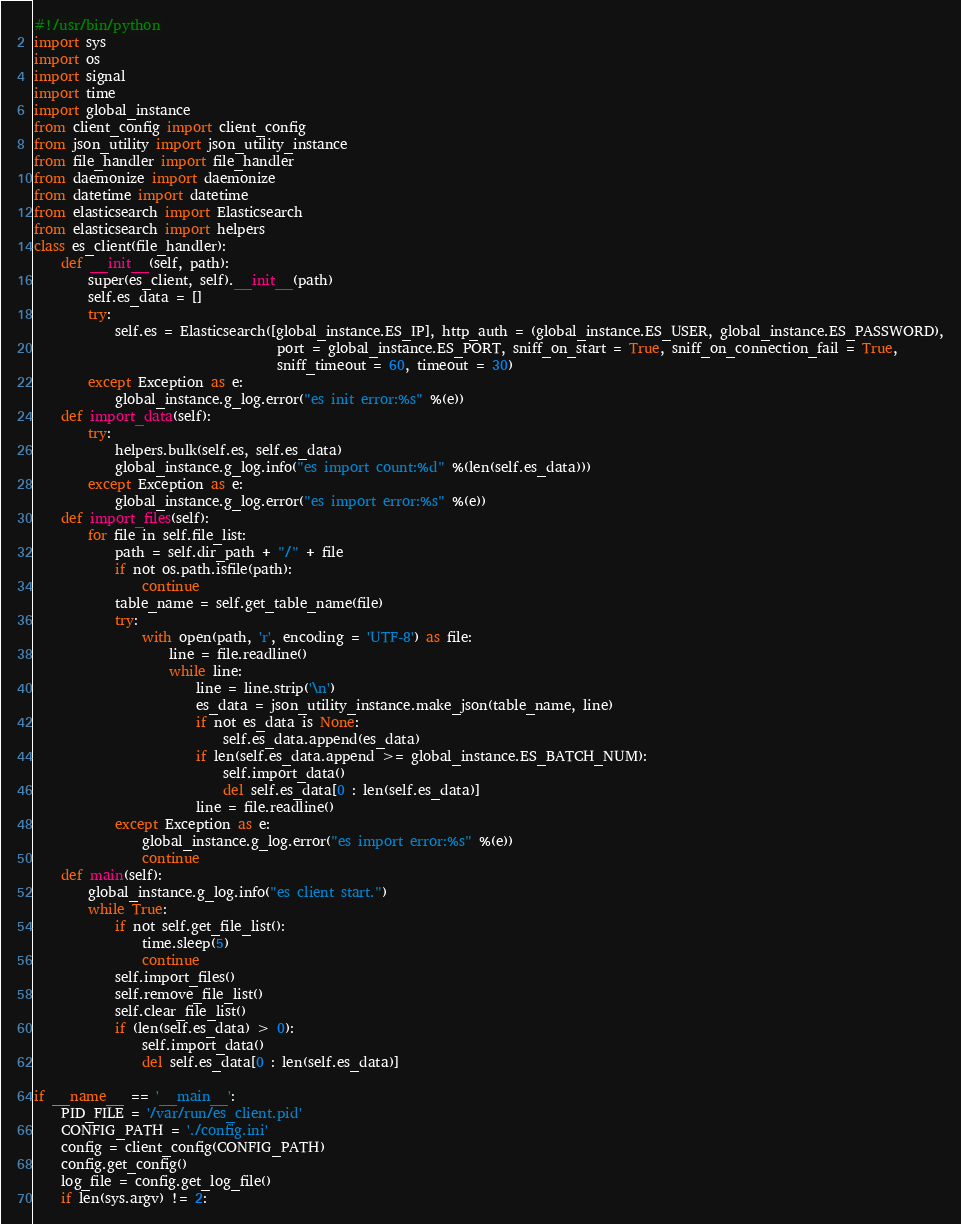Convert code to text. <code><loc_0><loc_0><loc_500><loc_500><_Python_>#!/usr/bin/python
import sys
import os
import signal
import time
import global_instance
from client_config import client_config
from json_utility import json_utility_instance
from file_handler import file_handler
from daemonize import daemonize
from datetime import datetime
from elasticsearch import Elasticsearch
from elasticsearch import helpers
class es_client(file_handler):
    def __init__(self, path):
        super(es_client, self).__init__(path)
        self.es_data = []
        try:
            self.es = Elasticsearch([global_instance.ES_IP], http_auth = (global_instance.ES_USER, global_instance.ES_PASSWORD),
                                    port = global_instance.ES_PORT, sniff_on_start = True, sniff_on_connection_fail = True,  
                                    sniff_timeout = 60, timeout = 30)
        except Exception as e:
            global_instance.g_log.error("es init error:%s" %(e))
    def import_data(self):
        try:
            helpers.bulk(self.es, self.es_data)
            global_instance.g_log.info("es import count:%d" %(len(self.es_data)))
        except Exception as e:
            global_instance.g_log.error("es import error:%s" %(e))
    def import_files(self):
        for file in self.file_list:
            path = self.dir_path + "/" + file
            if not os.path.isfile(path):
                continue
            table_name = self.get_table_name(file)
            try:
                with open(path, 'r', encoding = 'UTF-8') as file:
                    line = file.readline()
                    while line:
                        line = line.strip('\n')
                        es_data = json_utility_instance.make_json(table_name, line)
                        if not es_data is None:
                            self.es_data.append(es_data)
                        if len(self.es_data.append >= global_instance.ES_BATCH_NUM):
                            self.import_data()
                            del self.es_data[0 : len(self.es_data)]
                        line = file.readline()
            except Exception as e:
                global_instance.g_log.error("es import error:%s" %(e))
                continue
    def main(self):
        global_instance.g_log.info("es client start.")
        while True:
            if not self.get_file_list():
                time.sleep(5)
                continue
            self.import_files()
            self.remove_file_list()
            self.clear_file_list()
            if (len(self.es_data) > 0):
                self.import_data()
                del self.es_data[0 : len(self.es_data)]

if __name__ == '__main__':
    PID_FILE = '/var/run/es_client.pid'
    CONFIG_PATH = './config.ini'
    config = client_config(CONFIG_PATH)
    config.get_config()
    log_file = config.get_log_file()
    if len(sys.argv) != 2:</code> 